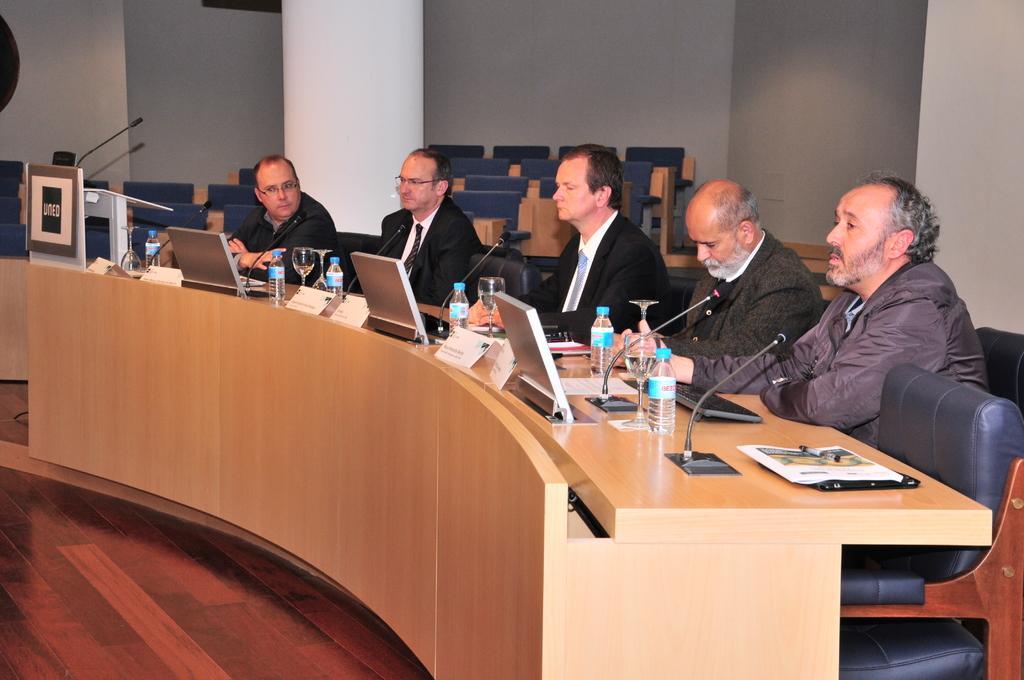Please provide a concise description of this image. There are five people sitting in front of a table in which every one is having a microphone in front of them and a monitor too. There is a table on which these were placed. There are some name plates, bottles and a glass on the table. In the background there is a pillar and a wall. 